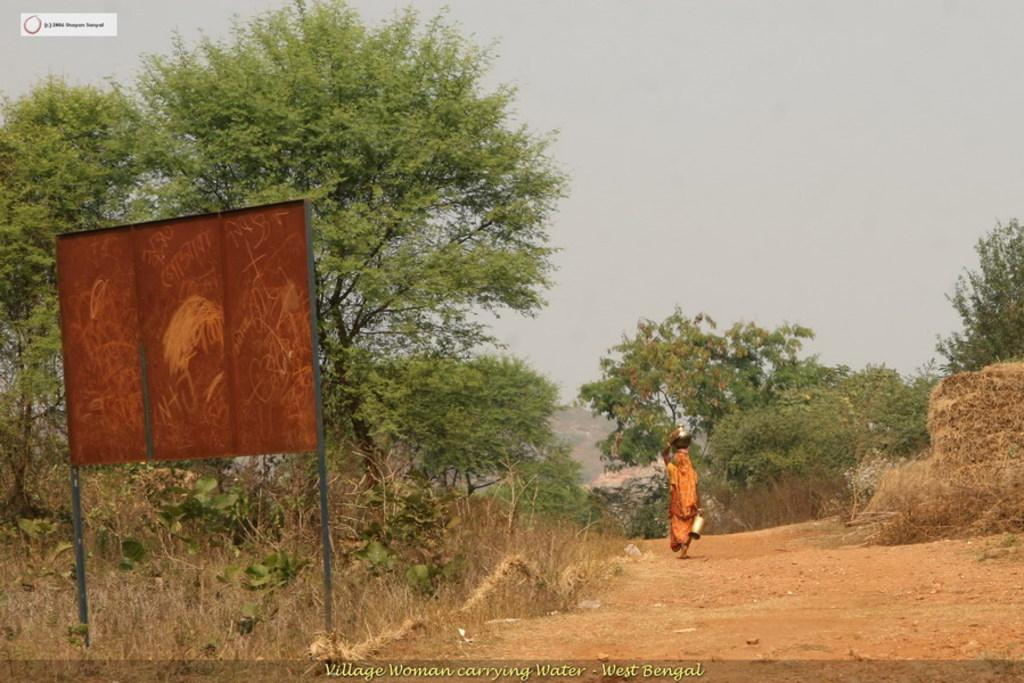What type of road is visible in the image? There is a mud road in the image. What is the lady in the image doing? The lady is holding vessels and walking. What can be seen in the background of the image? There are trees and the sky visible in the background of the image. Is there any text present in the image? Yes, there is text written at the bottom of the image. What is the lady's income in the image? There is no information about the lady's income in the image. How many light bulbs are visible in the image? There are no light bulbs present in the image. 